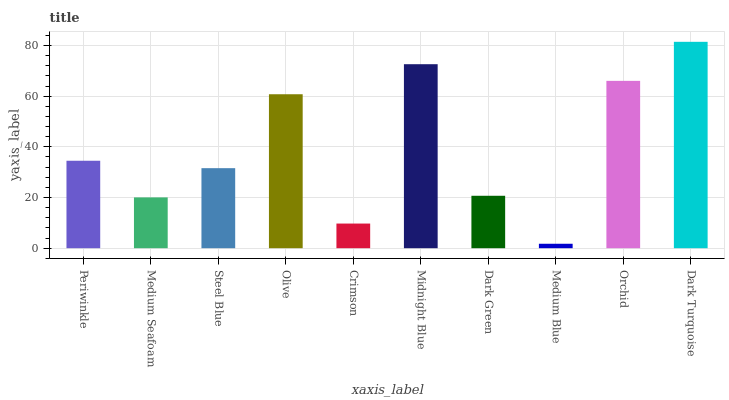Is Medium Blue the minimum?
Answer yes or no. Yes. Is Dark Turquoise the maximum?
Answer yes or no. Yes. Is Medium Seafoam the minimum?
Answer yes or no. No. Is Medium Seafoam the maximum?
Answer yes or no. No. Is Periwinkle greater than Medium Seafoam?
Answer yes or no. Yes. Is Medium Seafoam less than Periwinkle?
Answer yes or no. Yes. Is Medium Seafoam greater than Periwinkle?
Answer yes or no. No. Is Periwinkle less than Medium Seafoam?
Answer yes or no. No. Is Periwinkle the high median?
Answer yes or no. Yes. Is Steel Blue the low median?
Answer yes or no. Yes. Is Midnight Blue the high median?
Answer yes or no. No. Is Midnight Blue the low median?
Answer yes or no. No. 